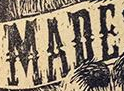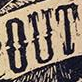Read the text from these images in sequence, separated by a semicolon. MADE; OUT 